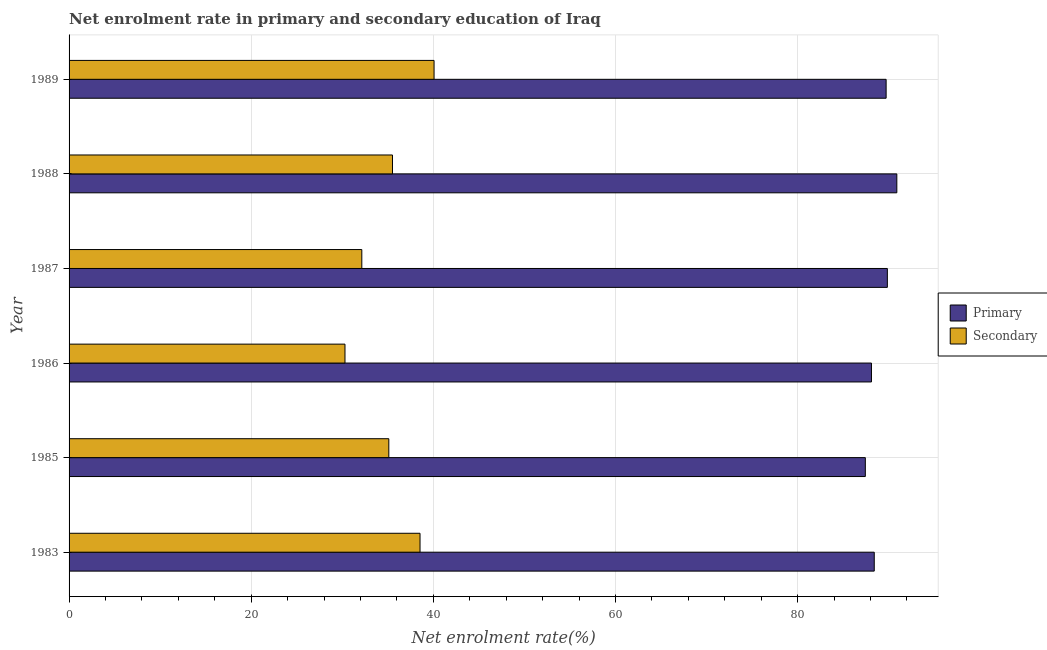How many different coloured bars are there?
Your response must be concise. 2. Are the number of bars per tick equal to the number of legend labels?
Give a very brief answer. Yes. Are the number of bars on each tick of the Y-axis equal?
Give a very brief answer. Yes. How many bars are there on the 1st tick from the top?
Ensure brevity in your answer.  2. What is the label of the 2nd group of bars from the top?
Offer a very short reply. 1988. What is the enrollment rate in primary education in 1989?
Offer a very short reply. 89.71. Across all years, what is the maximum enrollment rate in primary education?
Keep it short and to the point. 90.89. Across all years, what is the minimum enrollment rate in secondary education?
Give a very brief answer. 30.29. In which year was the enrollment rate in secondary education maximum?
Provide a short and direct response. 1989. What is the total enrollment rate in secondary education in the graph?
Provide a succinct answer. 211.66. What is the difference between the enrollment rate in primary education in 1983 and that in 1988?
Provide a succinct answer. -2.48. What is the difference between the enrollment rate in secondary education in 1985 and the enrollment rate in primary education in 1986?
Offer a terse response. -52.99. What is the average enrollment rate in primary education per year?
Make the answer very short. 89.06. In the year 1985, what is the difference between the enrollment rate in secondary education and enrollment rate in primary education?
Your answer should be very brief. -52.32. Is the enrollment rate in secondary education in 1985 less than that in 1986?
Offer a very short reply. No. Is the difference between the enrollment rate in primary education in 1983 and 1986 greater than the difference between the enrollment rate in secondary education in 1983 and 1986?
Offer a very short reply. No. What is the difference between the highest and the second highest enrollment rate in secondary education?
Provide a succinct answer. 1.54. What is the difference between the highest and the lowest enrollment rate in primary education?
Give a very brief answer. 3.46. Is the sum of the enrollment rate in primary education in 1987 and 1988 greater than the maximum enrollment rate in secondary education across all years?
Offer a very short reply. Yes. What does the 1st bar from the top in 1983 represents?
Provide a short and direct response. Secondary. What does the 2nd bar from the bottom in 1989 represents?
Your answer should be compact. Secondary. How many bars are there?
Provide a succinct answer. 12. How many years are there in the graph?
Keep it short and to the point. 6. Are the values on the major ticks of X-axis written in scientific E-notation?
Make the answer very short. No. Does the graph contain grids?
Offer a terse response. Yes. How many legend labels are there?
Provide a short and direct response. 2. What is the title of the graph?
Offer a terse response. Net enrolment rate in primary and secondary education of Iraq. Does "Unregistered firms" appear as one of the legend labels in the graph?
Keep it short and to the point. No. What is the label or title of the X-axis?
Your answer should be very brief. Net enrolment rate(%). What is the Net enrolment rate(%) in Primary in 1983?
Your response must be concise. 88.41. What is the Net enrolment rate(%) in Secondary in 1983?
Ensure brevity in your answer.  38.53. What is the Net enrolment rate(%) of Primary in 1985?
Give a very brief answer. 87.43. What is the Net enrolment rate(%) of Secondary in 1985?
Give a very brief answer. 35.11. What is the Net enrolment rate(%) in Primary in 1986?
Your answer should be compact. 88.1. What is the Net enrolment rate(%) of Secondary in 1986?
Your answer should be very brief. 30.29. What is the Net enrolment rate(%) of Primary in 1987?
Your answer should be very brief. 89.85. What is the Net enrolment rate(%) in Secondary in 1987?
Offer a terse response. 32.14. What is the Net enrolment rate(%) of Primary in 1988?
Provide a short and direct response. 90.89. What is the Net enrolment rate(%) in Secondary in 1988?
Offer a terse response. 35.51. What is the Net enrolment rate(%) of Primary in 1989?
Your answer should be very brief. 89.71. What is the Net enrolment rate(%) in Secondary in 1989?
Offer a very short reply. 40.07. Across all years, what is the maximum Net enrolment rate(%) in Primary?
Offer a terse response. 90.89. Across all years, what is the maximum Net enrolment rate(%) of Secondary?
Provide a short and direct response. 40.07. Across all years, what is the minimum Net enrolment rate(%) in Primary?
Offer a terse response. 87.43. Across all years, what is the minimum Net enrolment rate(%) of Secondary?
Your response must be concise. 30.29. What is the total Net enrolment rate(%) in Primary in the graph?
Make the answer very short. 534.38. What is the total Net enrolment rate(%) in Secondary in the graph?
Keep it short and to the point. 211.66. What is the difference between the Net enrolment rate(%) in Primary in 1983 and that in 1985?
Your answer should be very brief. 0.98. What is the difference between the Net enrolment rate(%) of Secondary in 1983 and that in 1985?
Keep it short and to the point. 3.43. What is the difference between the Net enrolment rate(%) in Primary in 1983 and that in 1986?
Offer a terse response. 0.31. What is the difference between the Net enrolment rate(%) in Secondary in 1983 and that in 1986?
Offer a terse response. 8.24. What is the difference between the Net enrolment rate(%) in Primary in 1983 and that in 1987?
Provide a short and direct response. -1.44. What is the difference between the Net enrolment rate(%) in Secondary in 1983 and that in 1987?
Provide a short and direct response. 6.39. What is the difference between the Net enrolment rate(%) in Primary in 1983 and that in 1988?
Offer a terse response. -2.48. What is the difference between the Net enrolment rate(%) of Secondary in 1983 and that in 1988?
Your answer should be very brief. 3.03. What is the difference between the Net enrolment rate(%) of Primary in 1983 and that in 1989?
Provide a succinct answer. -1.3. What is the difference between the Net enrolment rate(%) in Secondary in 1983 and that in 1989?
Give a very brief answer. -1.54. What is the difference between the Net enrolment rate(%) in Primary in 1985 and that in 1986?
Make the answer very short. -0.67. What is the difference between the Net enrolment rate(%) of Secondary in 1985 and that in 1986?
Ensure brevity in your answer.  4.81. What is the difference between the Net enrolment rate(%) of Primary in 1985 and that in 1987?
Keep it short and to the point. -2.42. What is the difference between the Net enrolment rate(%) in Secondary in 1985 and that in 1987?
Ensure brevity in your answer.  2.97. What is the difference between the Net enrolment rate(%) of Primary in 1985 and that in 1988?
Keep it short and to the point. -3.46. What is the difference between the Net enrolment rate(%) of Secondary in 1985 and that in 1988?
Offer a terse response. -0.4. What is the difference between the Net enrolment rate(%) in Primary in 1985 and that in 1989?
Your answer should be very brief. -2.28. What is the difference between the Net enrolment rate(%) in Secondary in 1985 and that in 1989?
Provide a short and direct response. -4.97. What is the difference between the Net enrolment rate(%) of Primary in 1986 and that in 1987?
Make the answer very short. -1.75. What is the difference between the Net enrolment rate(%) in Secondary in 1986 and that in 1987?
Keep it short and to the point. -1.85. What is the difference between the Net enrolment rate(%) in Primary in 1986 and that in 1988?
Your answer should be very brief. -2.78. What is the difference between the Net enrolment rate(%) in Secondary in 1986 and that in 1988?
Provide a succinct answer. -5.22. What is the difference between the Net enrolment rate(%) in Primary in 1986 and that in 1989?
Provide a short and direct response. -1.61. What is the difference between the Net enrolment rate(%) in Secondary in 1986 and that in 1989?
Make the answer very short. -9.78. What is the difference between the Net enrolment rate(%) in Primary in 1987 and that in 1988?
Your answer should be compact. -1.04. What is the difference between the Net enrolment rate(%) in Secondary in 1987 and that in 1988?
Ensure brevity in your answer.  -3.37. What is the difference between the Net enrolment rate(%) in Primary in 1987 and that in 1989?
Your answer should be compact. 0.13. What is the difference between the Net enrolment rate(%) in Secondary in 1987 and that in 1989?
Provide a succinct answer. -7.93. What is the difference between the Net enrolment rate(%) of Primary in 1988 and that in 1989?
Ensure brevity in your answer.  1.17. What is the difference between the Net enrolment rate(%) of Secondary in 1988 and that in 1989?
Make the answer very short. -4.57. What is the difference between the Net enrolment rate(%) in Primary in 1983 and the Net enrolment rate(%) in Secondary in 1985?
Ensure brevity in your answer.  53.3. What is the difference between the Net enrolment rate(%) of Primary in 1983 and the Net enrolment rate(%) of Secondary in 1986?
Make the answer very short. 58.11. What is the difference between the Net enrolment rate(%) in Primary in 1983 and the Net enrolment rate(%) in Secondary in 1987?
Provide a succinct answer. 56.27. What is the difference between the Net enrolment rate(%) of Primary in 1983 and the Net enrolment rate(%) of Secondary in 1988?
Offer a terse response. 52.9. What is the difference between the Net enrolment rate(%) of Primary in 1983 and the Net enrolment rate(%) of Secondary in 1989?
Your response must be concise. 48.33. What is the difference between the Net enrolment rate(%) of Primary in 1985 and the Net enrolment rate(%) of Secondary in 1986?
Keep it short and to the point. 57.13. What is the difference between the Net enrolment rate(%) of Primary in 1985 and the Net enrolment rate(%) of Secondary in 1987?
Ensure brevity in your answer.  55.29. What is the difference between the Net enrolment rate(%) of Primary in 1985 and the Net enrolment rate(%) of Secondary in 1988?
Offer a terse response. 51.92. What is the difference between the Net enrolment rate(%) of Primary in 1985 and the Net enrolment rate(%) of Secondary in 1989?
Your answer should be compact. 47.35. What is the difference between the Net enrolment rate(%) of Primary in 1986 and the Net enrolment rate(%) of Secondary in 1987?
Your response must be concise. 55.96. What is the difference between the Net enrolment rate(%) of Primary in 1986 and the Net enrolment rate(%) of Secondary in 1988?
Your answer should be compact. 52.59. What is the difference between the Net enrolment rate(%) in Primary in 1986 and the Net enrolment rate(%) in Secondary in 1989?
Your response must be concise. 48.03. What is the difference between the Net enrolment rate(%) in Primary in 1987 and the Net enrolment rate(%) in Secondary in 1988?
Make the answer very short. 54.34. What is the difference between the Net enrolment rate(%) in Primary in 1987 and the Net enrolment rate(%) in Secondary in 1989?
Provide a succinct answer. 49.77. What is the difference between the Net enrolment rate(%) in Primary in 1988 and the Net enrolment rate(%) in Secondary in 1989?
Give a very brief answer. 50.81. What is the average Net enrolment rate(%) in Primary per year?
Your answer should be very brief. 89.06. What is the average Net enrolment rate(%) in Secondary per year?
Your response must be concise. 35.28. In the year 1983, what is the difference between the Net enrolment rate(%) of Primary and Net enrolment rate(%) of Secondary?
Provide a succinct answer. 49.87. In the year 1985, what is the difference between the Net enrolment rate(%) in Primary and Net enrolment rate(%) in Secondary?
Offer a terse response. 52.32. In the year 1986, what is the difference between the Net enrolment rate(%) in Primary and Net enrolment rate(%) in Secondary?
Keep it short and to the point. 57.81. In the year 1987, what is the difference between the Net enrolment rate(%) of Primary and Net enrolment rate(%) of Secondary?
Make the answer very short. 57.7. In the year 1988, what is the difference between the Net enrolment rate(%) in Primary and Net enrolment rate(%) in Secondary?
Your answer should be very brief. 55.38. In the year 1989, what is the difference between the Net enrolment rate(%) of Primary and Net enrolment rate(%) of Secondary?
Provide a short and direct response. 49.64. What is the ratio of the Net enrolment rate(%) in Primary in 1983 to that in 1985?
Give a very brief answer. 1.01. What is the ratio of the Net enrolment rate(%) in Secondary in 1983 to that in 1985?
Provide a succinct answer. 1.1. What is the ratio of the Net enrolment rate(%) in Primary in 1983 to that in 1986?
Make the answer very short. 1. What is the ratio of the Net enrolment rate(%) of Secondary in 1983 to that in 1986?
Your answer should be very brief. 1.27. What is the ratio of the Net enrolment rate(%) of Secondary in 1983 to that in 1987?
Offer a terse response. 1.2. What is the ratio of the Net enrolment rate(%) in Primary in 1983 to that in 1988?
Provide a succinct answer. 0.97. What is the ratio of the Net enrolment rate(%) in Secondary in 1983 to that in 1988?
Offer a terse response. 1.09. What is the ratio of the Net enrolment rate(%) of Primary in 1983 to that in 1989?
Your answer should be compact. 0.99. What is the ratio of the Net enrolment rate(%) in Secondary in 1983 to that in 1989?
Provide a short and direct response. 0.96. What is the ratio of the Net enrolment rate(%) in Secondary in 1985 to that in 1986?
Provide a succinct answer. 1.16. What is the ratio of the Net enrolment rate(%) in Primary in 1985 to that in 1987?
Make the answer very short. 0.97. What is the ratio of the Net enrolment rate(%) in Secondary in 1985 to that in 1987?
Your answer should be very brief. 1.09. What is the ratio of the Net enrolment rate(%) of Primary in 1985 to that in 1988?
Provide a short and direct response. 0.96. What is the ratio of the Net enrolment rate(%) of Secondary in 1985 to that in 1988?
Your response must be concise. 0.99. What is the ratio of the Net enrolment rate(%) of Primary in 1985 to that in 1989?
Make the answer very short. 0.97. What is the ratio of the Net enrolment rate(%) of Secondary in 1985 to that in 1989?
Provide a succinct answer. 0.88. What is the ratio of the Net enrolment rate(%) of Primary in 1986 to that in 1987?
Make the answer very short. 0.98. What is the ratio of the Net enrolment rate(%) of Secondary in 1986 to that in 1987?
Offer a very short reply. 0.94. What is the ratio of the Net enrolment rate(%) in Primary in 1986 to that in 1988?
Make the answer very short. 0.97. What is the ratio of the Net enrolment rate(%) in Secondary in 1986 to that in 1988?
Keep it short and to the point. 0.85. What is the ratio of the Net enrolment rate(%) in Secondary in 1986 to that in 1989?
Give a very brief answer. 0.76. What is the ratio of the Net enrolment rate(%) of Secondary in 1987 to that in 1988?
Your answer should be very brief. 0.91. What is the ratio of the Net enrolment rate(%) in Primary in 1987 to that in 1989?
Your response must be concise. 1. What is the ratio of the Net enrolment rate(%) in Secondary in 1987 to that in 1989?
Your answer should be very brief. 0.8. What is the ratio of the Net enrolment rate(%) of Primary in 1988 to that in 1989?
Offer a very short reply. 1.01. What is the ratio of the Net enrolment rate(%) in Secondary in 1988 to that in 1989?
Your answer should be very brief. 0.89. What is the difference between the highest and the second highest Net enrolment rate(%) of Primary?
Give a very brief answer. 1.04. What is the difference between the highest and the second highest Net enrolment rate(%) in Secondary?
Ensure brevity in your answer.  1.54. What is the difference between the highest and the lowest Net enrolment rate(%) of Primary?
Offer a very short reply. 3.46. What is the difference between the highest and the lowest Net enrolment rate(%) of Secondary?
Your response must be concise. 9.78. 